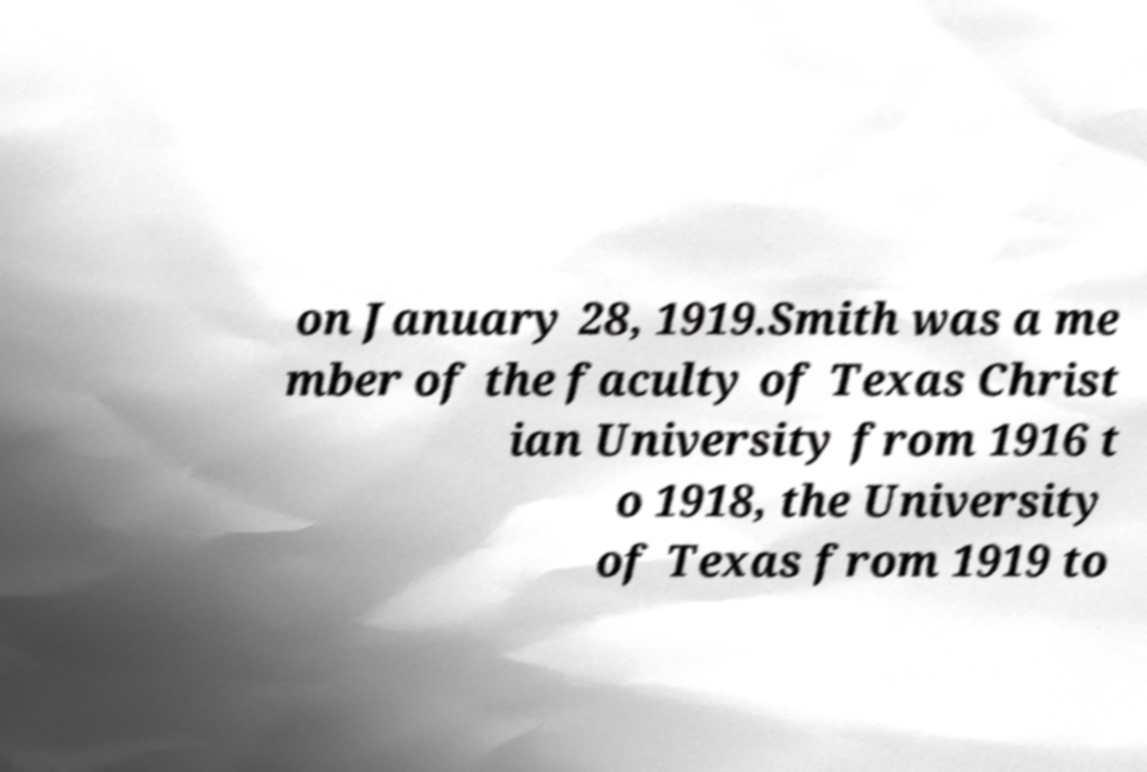Could you assist in decoding the text presented in this image and type it out clearly? on January 28, 1919.Smith was a me mber of the faculty of Texas Christ ian University from 1916 t o 1918, the University of Texas from 1919 to 